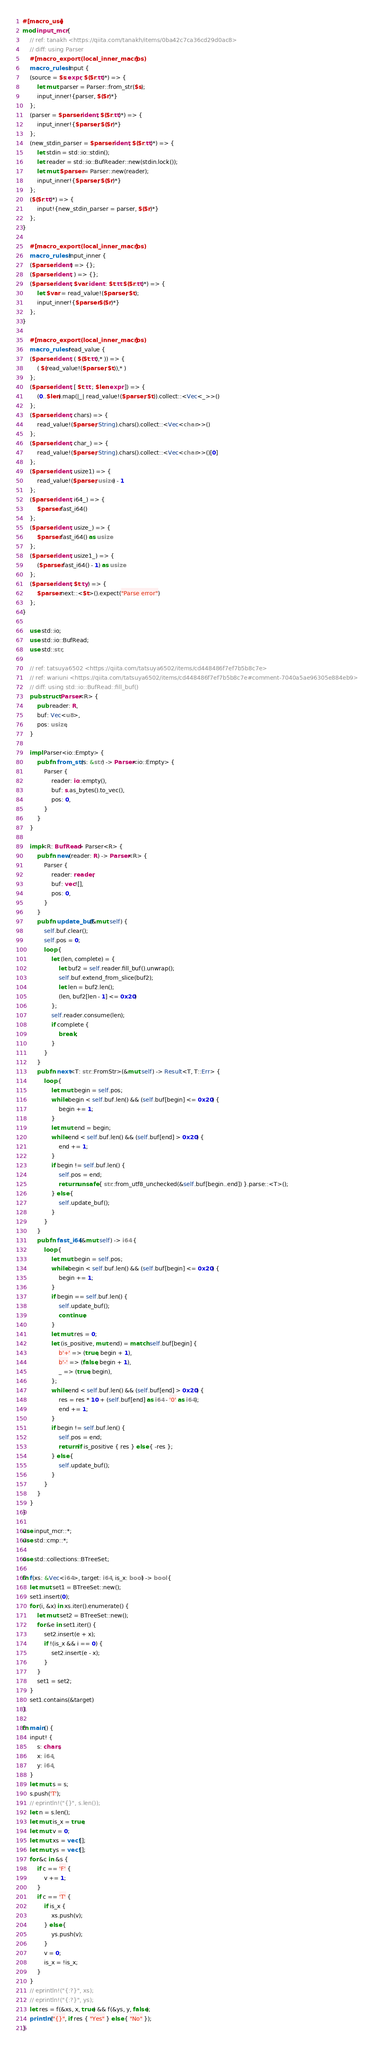Convert code to text. <code><loc_0><loc_0><loc_500><loc_500><_Rust_>#[macro_use]
mod input_mcr {
    // ref: tanakh <https://qiita.com/tanakh/items/0ba42c7ca36cd29d0ac8>
    // diff: using Parser
    #[macro_export(local_inner_macros)]
    macro_rules! input {
    (source = $s:expr, $($r:tt)*) => {
        let mut parser = Parser::from_str($s);
        input_inner!{parser, $($r)*}
    };
    (parser = $parser:ident, $($r:tt)*) => {
        input_inner!{$parser, $($r)*}
    };
    (new_stdin_parser = $parser:ident, $($r:tt)*) => {
        let stdin = std::io::stdin();
        let reader = std::io::BufReader::new(stdin.lock());
        let mut $parser = Parser::new(reader);
        input_inner!{$parser, $($r)*}
    };
    ($($r:tt)*) => {
        input!{new_stdin_parser = parser, $($r)*}
    };
}

    #[macro_export(local_inner_macros)]
    macro_rules! input_inner {
    ($parser:ident) => {};
    ($parser:ident, ) => {};
    ($parser:ident, $var:ident : $t:tt $($r:tt)*) => {
        let $var = read_value!($parser, $t);
        input_inner!{$parser $($r)*}
    };
}

    #[macro_export(local_inner_macros)]
    macro_rules! read_value {
    ($parser:ident, ( $($t:tt),* )) => {
        ( $(read_value!($parser, $t)),* )
    };
    ($parser:ident, [ $t:tt ; $len:expr ]) => {
        (0..$len).map(|_| read_value!($parser, $t)).collect::<Vec<_>>()
    };
    ($parser:ident, chars) => {
        read_value!($parser, String).chars().collect::<Vec<char>>()
    };
    ($parser:ident, char_) => {
        read_value!($parser, String).chars().collect::<Vec<char>>()[0]
    };
    ($parser:ident, usize1) => {
        read_value!($parser, usize) - 1
    };
    ($parser:ident, i64_) => {
        $parser.fast_i64()
    };
    ($parser:ident, usize_) => {
        $parser.fast_i64() as usize
    };
    ($parser:ident, usize1_) => {
        ($parser.fast_i64() - 1) as usize
    };
    ($parser:ident, $t:ty) => {
        $parser.next::<$t>().expect("Parse error")
    };
}

    use std::io;
    use std::io::BufRead;
    use std::str;

    // ref: tatsuya6502 <https://qiita.com/tatsuya6502/items/cd448486f7ef7b5b8c7e>
    // ref: wariuni <https://qiita.com/tatsuya6502/items/cd448486f7ef7b5b8c7e#comment-7040a5ae96305e884eb9>
    // diff: using std::io::BufRead::fill_buf()
    pub struct Parser<R> {
        pub reader: R,
        buf: Vec<u8>,
        pos: usize,
    }

    impl Parser<io::Empty> {
        pub fn from_str(s: &str) -> Parser<io::Empty> {
            Parser {
                reader: io::empty(),
                buf: s.as_bytes().to_vec(),
                pos: 0,
            }
        }
    }

    impl<R: BufRead> Parser<R> {
        pub fn new(reader: R) -> Parser<R> {
            Parser {
                reader: reader,
                buf: vec![],
                pos: 0,
            }
        }
        pub fn update_buf(&mut self) {
            self.buf.clear();
            self.pos = 0;
            loop {
                let (len, complete) = {
                    let buf2 = self.reader.fill_buf().unwrap();
                    self.buf.extend_from_slice(buf2);
                    let len = buf2.len();
                    (len, buf2[len - 1] <= 0x20)
                };
                self.reader.consume(len);
                if complete {
                    break;
                }
            }
        }
        pub fn next<T: str::FromStr>(&mut self) -> Result<T, T::Err> {
            loop {
                let mut begin = self.pos;
                while begin < self.buf.len() && (self.buf[begin] <= 0x20) {
                    begin += 1;
                }
                let mut end = begin;
                while end < self.buf.len() && (self.buf[end] > 0x20) {
                    end += 1;
                }
                if begin != self.buf.len() {
                    self.pos = end;
                    return unsafe { str::from_utf8_unchecked(&self.buf[begin..end]) }.parse::<T>();
                } else {
                    self.update_buf();
                }
            }
        }
        pub fn fast_i64(&mut self) -> i64 {
            loop {
                let mut begin = self.pos;
                while begin < self.buf.len() && (self.buf[begin] <= 0x20) {
                    begin += 1;
                }
                if begin == self.buf.len() {
                    self.update_buf();
                    continue;
                }
                let mut res = 0;
                let (is_positive, mut end) = match self.buf[begin] {
                    b'+' => (true, begin + 1),
                    b'-' => (false, begin + 1),
                    _ => (true, begin),
                };
                while end < self.buf.len() && (self.buf[end] > 0x20) {
                    res = res * 10 + (self.buf[end] as i64 - '0' as i64);
                    end += 1;
                }
                if begin != self.buf.len() {
                    self.pos = end;
                    return if is_positive { res } else { -res };
                } else {
                    self.update_buf();
                }
            }
        }
    }
}

use input_mcr::*;
use std::cmp::*;

use std::collections::BTreeSet;

fn f(xs: &Vec<i64>, target: i64, is_x: bool) -> bool {
    let mut set1 = BTreeSet::new();
    set1.insert(0);
    for (i, &x) in xs.iter().enumerate() {
        let mut set2 = BTreeSet::new();
        for &e in set1.iter() {
            set2.insert(e + x);
            if !(is_x && i == 0) {
                set2.insert(e - x);
            }
        }
        set1 = set2;
    }
    set1.contains(&target)
}

fn main() {
    input! {
        s: chars,
        x: i64,
        y: i64,
    }
    let mut s = s;
    s.push('T');
    // eprintln!("{}", s.len());
    let n = s.len();
    let mut is_x = true;
    let mut v = 0;
    let mut xs = vec![];
    let mut ys = vec![];
    for &c in &s {
        if c == 'F' {
            v += 1;
        }
        if c == 'T' {
            if is_x {
                xs.push(v);
            } else {
                ys.push(v);
            }
            v = 0;
            is_x = !is_x;
        }
    }
    // eprintln!("{:?}", xs);
    // eprintln!("{:?}", ys);
    let res = f(&xs, x, true) && f(&ys, y, false);
    println!("{}", if res { "Yes" } else { "No" });
}

</code> 